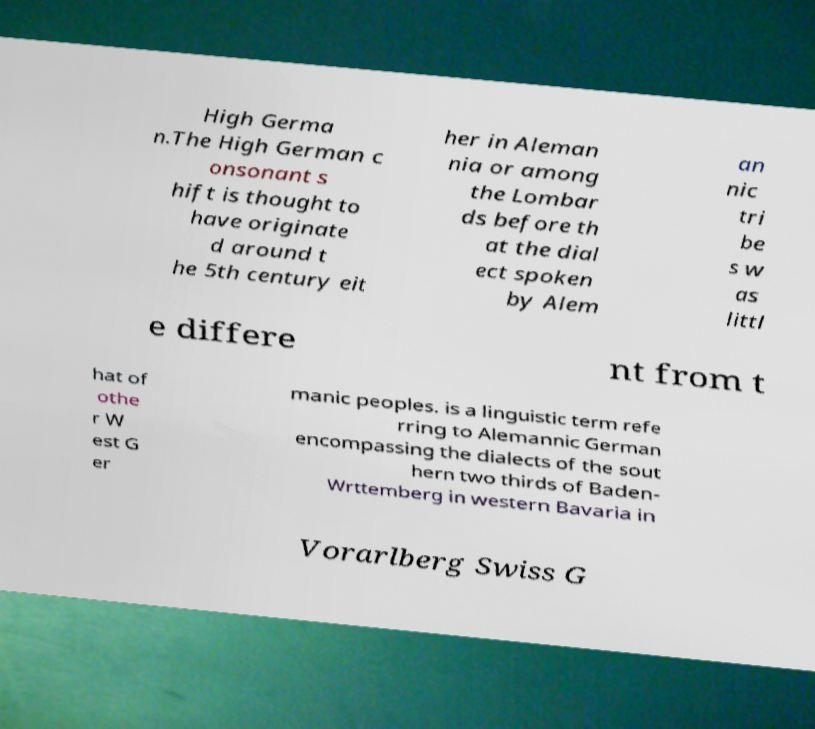Can you read and provide the text displayed in the image?This photo seems to have some interesting text. Can you extract and type it out for me? High Germa n.The High German c onsonant s hift is thought to have originate d around t he 5th century eit her in Aleman nia or among the Lombar ds before th at the dial ect spoken by Alem an nic tri be s w as littl e differe nt from t hat of othe r W est G er manic peoples. is a linguistic term refe rring to Alemannic German encompassing the dialects of the sout hern two thirds of Baden- Wrttemberg in western Bavaria in Vorarlberg Swiss G 